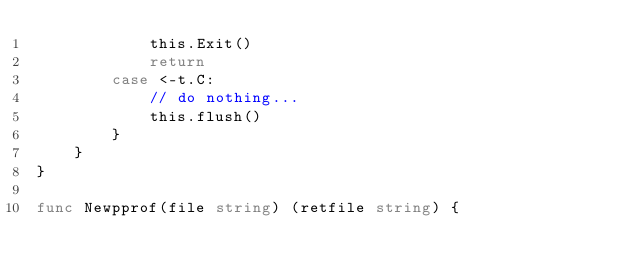Convert code to text. <code><loc_0><loc_0><loc_500><loc_500><_Go_>			this.Exit()
			return
		case <-t.C:
			// do nothing...
			this.flush()
		}
	}
}

func Newpprof(file string) (retfile string) {</code> 